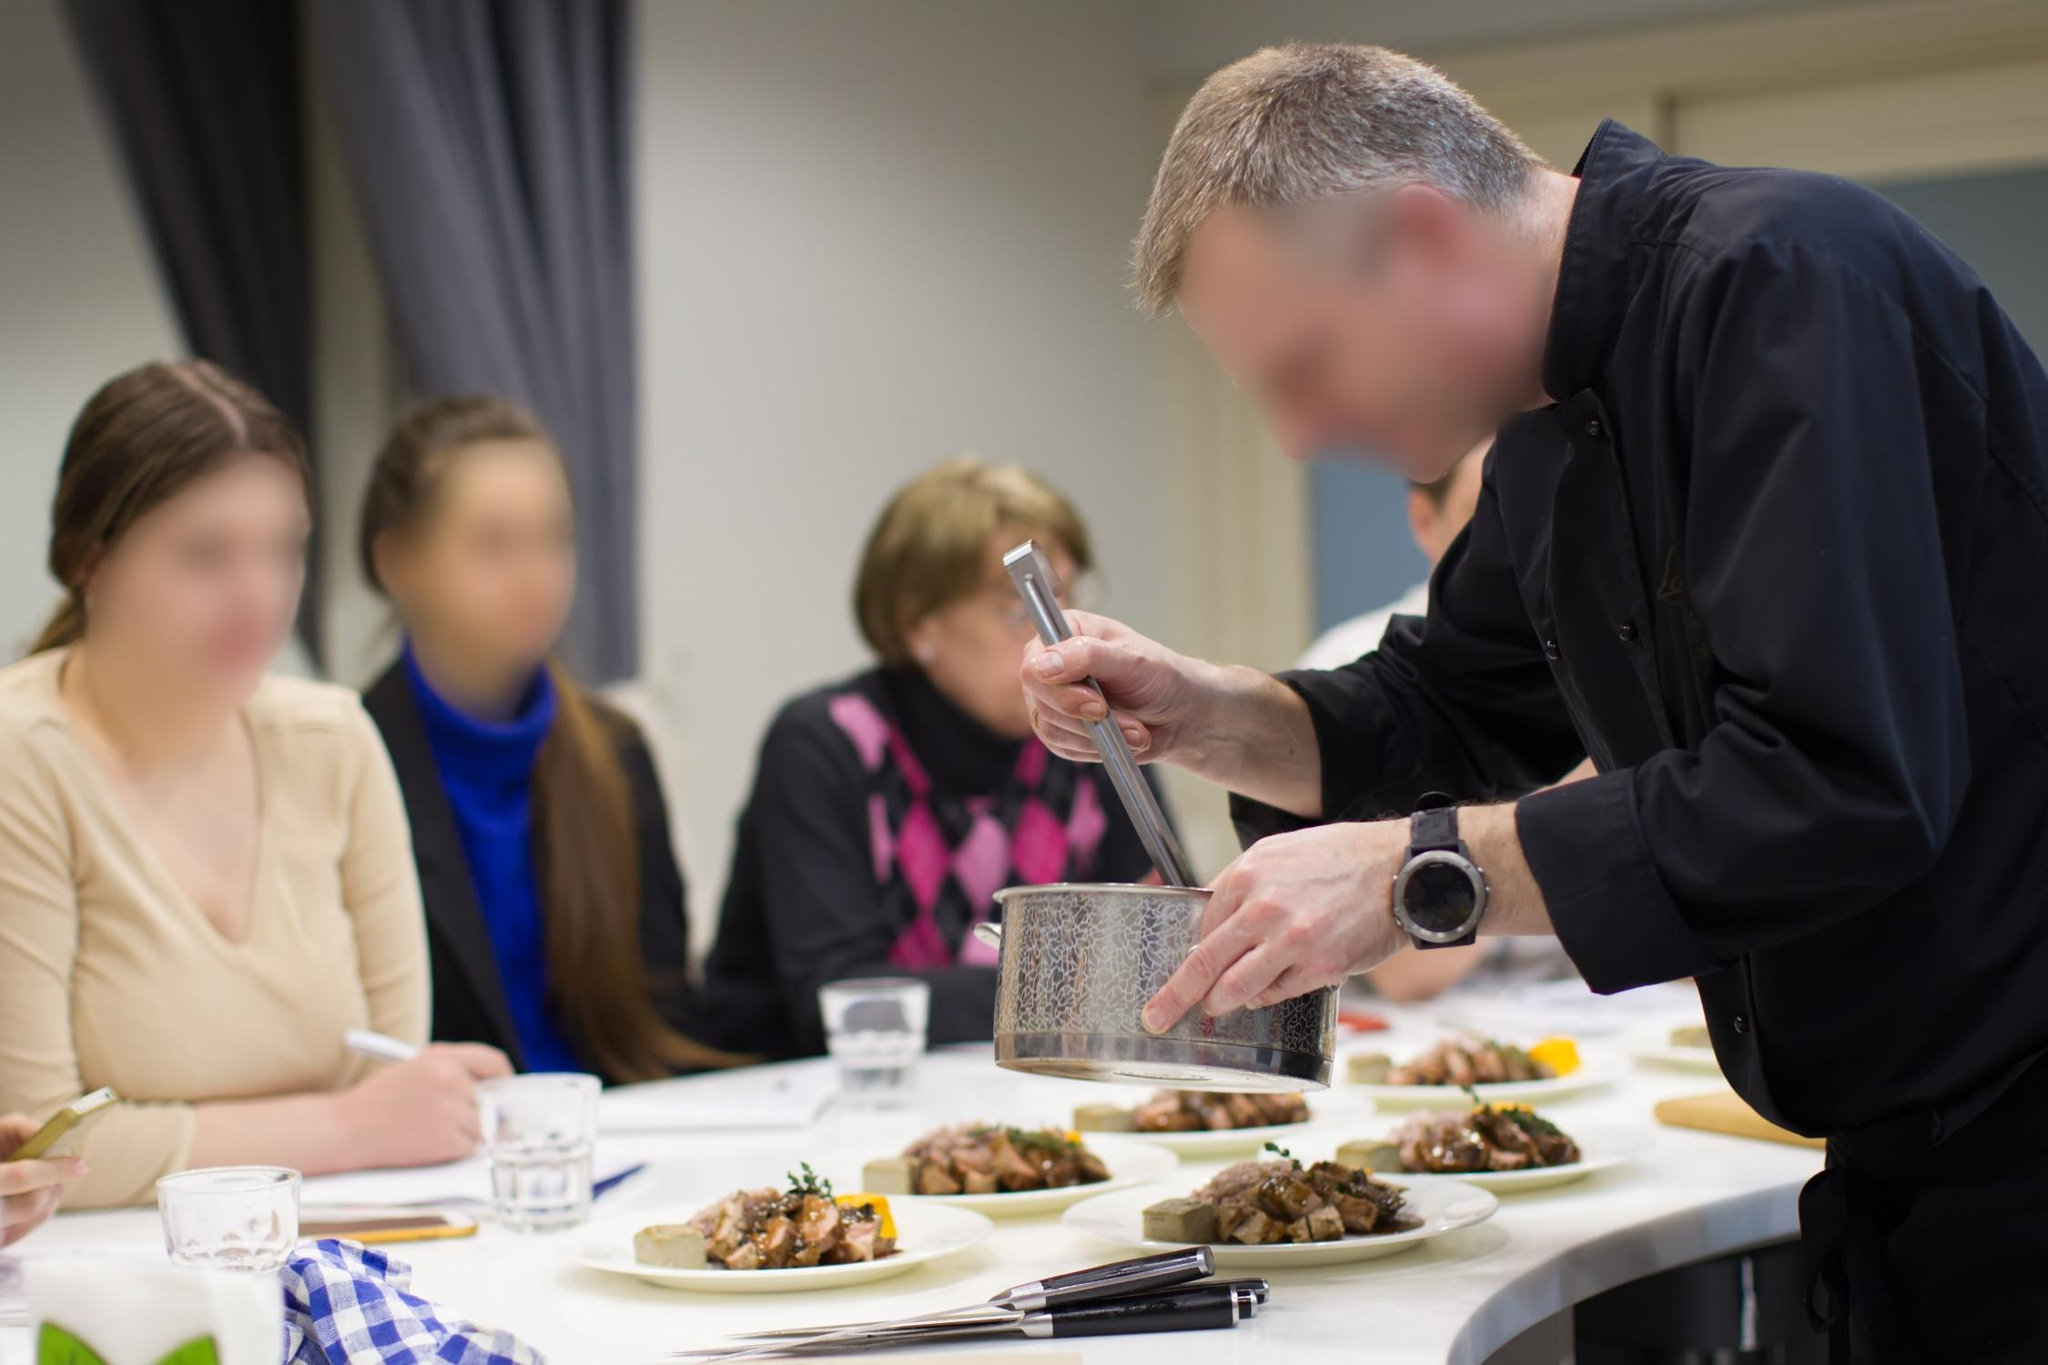Imagine the conversation between the chef and the spectators. What might they be saying? The spectators might be asking the chef questions like, 'What kind of cheese are you using?' or 'Can you explain the technique you're using to grate the cheese?' The chef might respond with, 'I'm using a freshly aged Parmesan for its rich and nutty flavor, which perfectly complements the other ingredients in this dish,' and 'Sure, always use gentle and even pressure to get uniform shreds without the cheese crumbling apart.' Such exchanges would enrich the learning experience, providing the spectators with valuable cooking insights. 